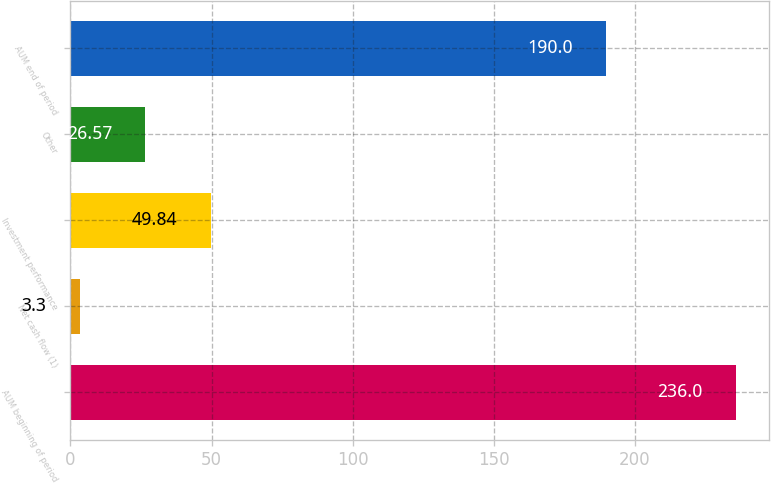Convert chart. <chart><loc_0><loc_0><loc_500><loc_500><bar_chart><fcel>AUM beginning of period<fcel>Net cash flow (1)<fcel>Investment performance<fcel>Other<fcel>AUM end of period<nl><fcel>236<fcel>3.3<fcel>49.84<fcel>26.57<fcel>190<nl></chart> 